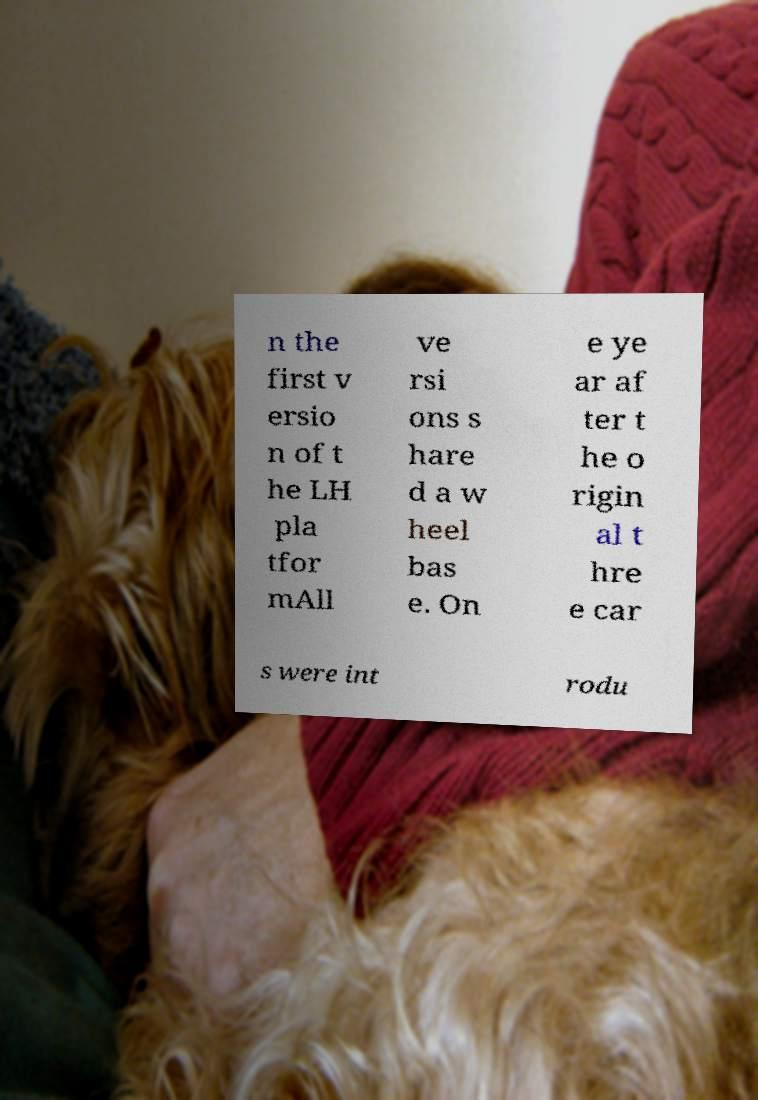I need the written content from this picture converted into text. Can you do that? n the first v ersio n of t he LH pla tfor mAll ve rsi ons s hare d a w heel bas e. On e ye ar af ter t he o rigin al t hre e car s were int rodu 